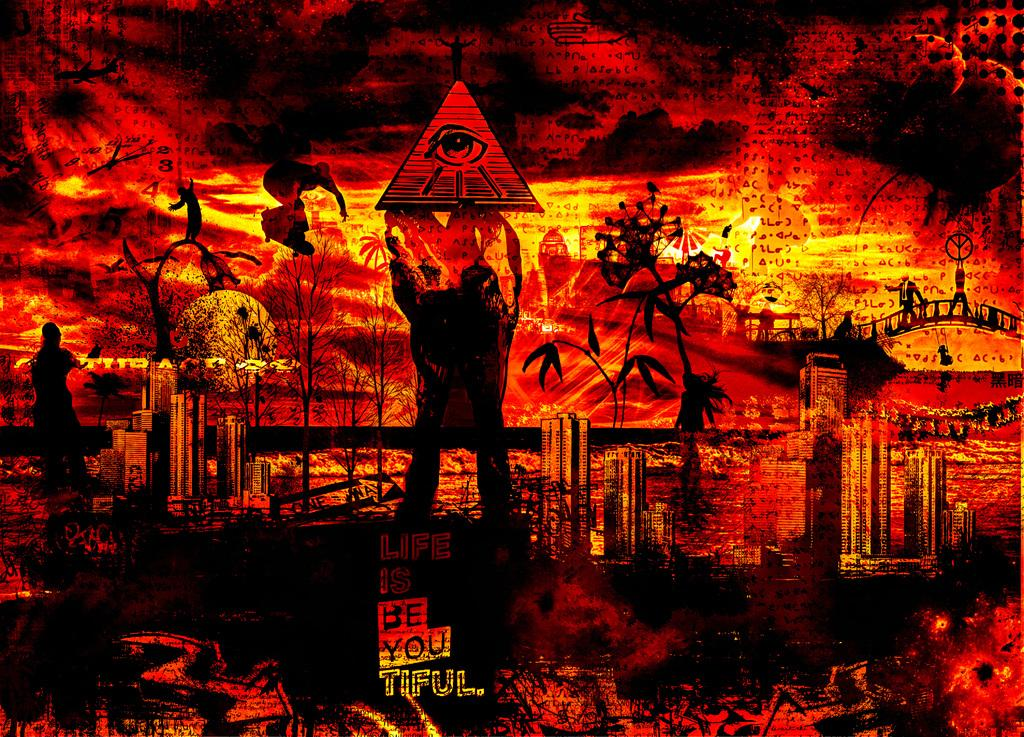Provide a one-sentence caption for the provided image. dark cataclysmic picture of someone holding a triangle with an eye in eye and words at bottom of picture be you tiful. 